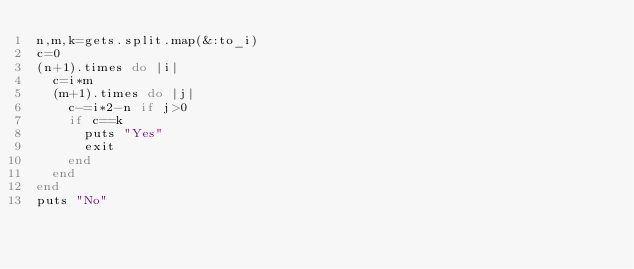Convert code to text. <code><loc_0><loc_0><loc_500><loc_500><_Ruby_>n,m,k=gets.split.map(&:to_i)
c=0
(n+1).times do |i|
  c=i*m
  (m+1).times do |j|
    c-=i*2-n if j>0
    if c==k
      puts "Yes"
      exit
    end
  end
end
puts "No"</code> 